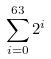<formula> <loc_0><loc_0><loc_500><loc_500>\sum _ { i = 0 } ^ { 6 3 } 2 ^ { i }</formula> 